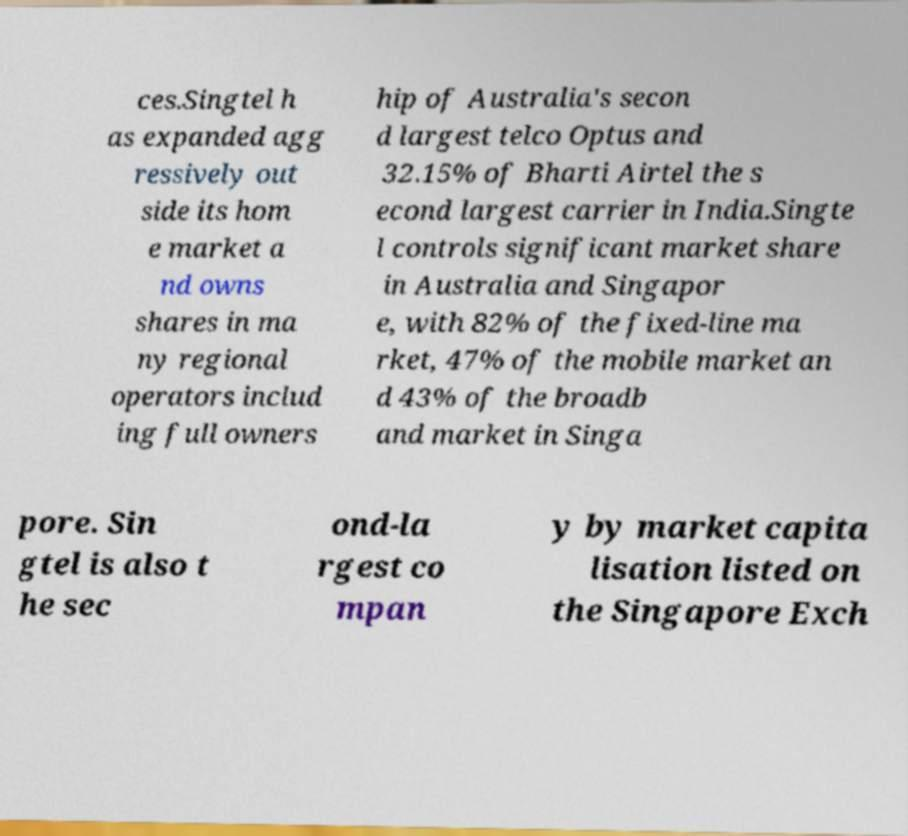Can you accurately transcribe the text from the provided image for me? ces.Singtel h as expanded agg ressively out side its hom e market a nd owns shares in ma ny regional operators includ ing full owners hip of Australia's secon d largest telco Optus and 32.15% of Bharti Airtel the s econd largest carrier in India.Singte l controls significant market share in Australia and Singapor e, with 82% of the fixed-line ma rket, 47% of the mobile market an d 43% of the broadb and market in Singa pore. Sin gtel is also t he sec ond-la rgest co mpan y by market capita lisation listed on the Singapore Exch 